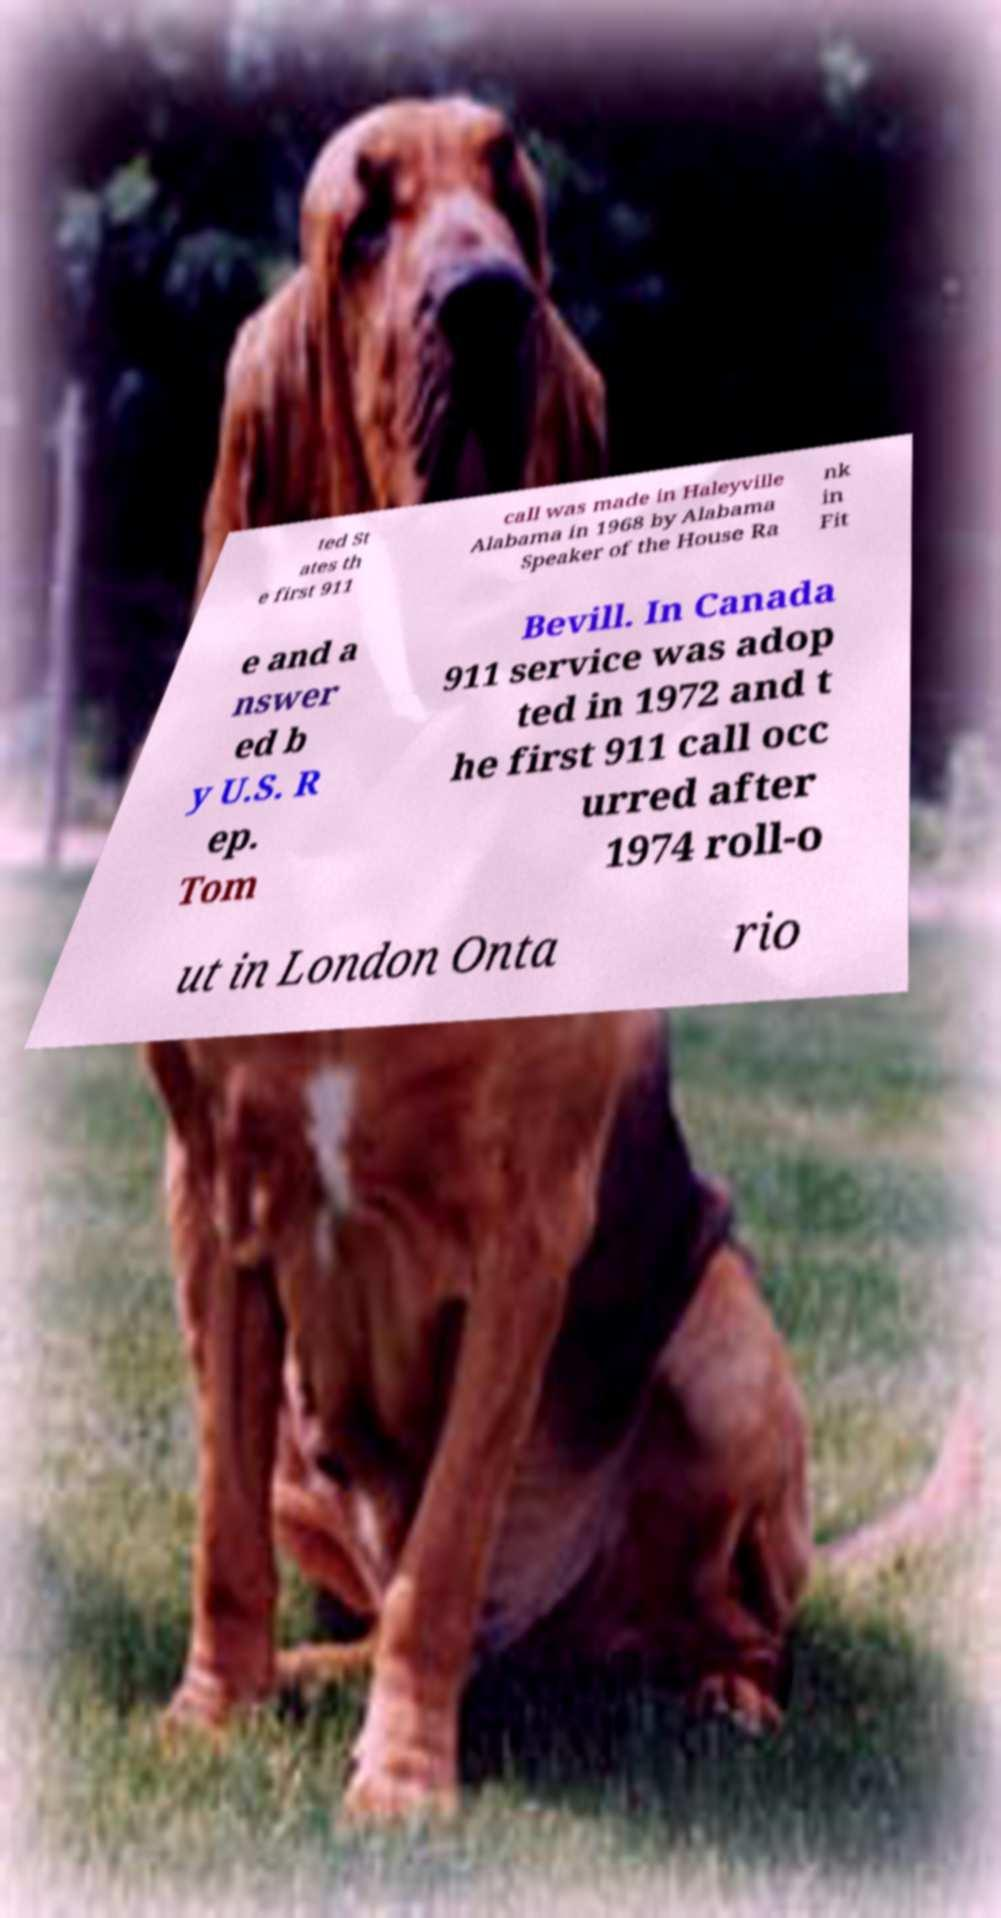Could you assist in decoding the text presented in this image and type it out clearly? ted St ates th e first 911 call was made in Haleyville Alabama in 1968 by Alabama Speaker of the House Ra nk in Fit e and a nswer ed b y U.S. R ep. Tom Bevill. In Canada 911 service was adop ted in 1972 and t he first 911 call occ urred after 1974 roll-o ut in London Onta rio 